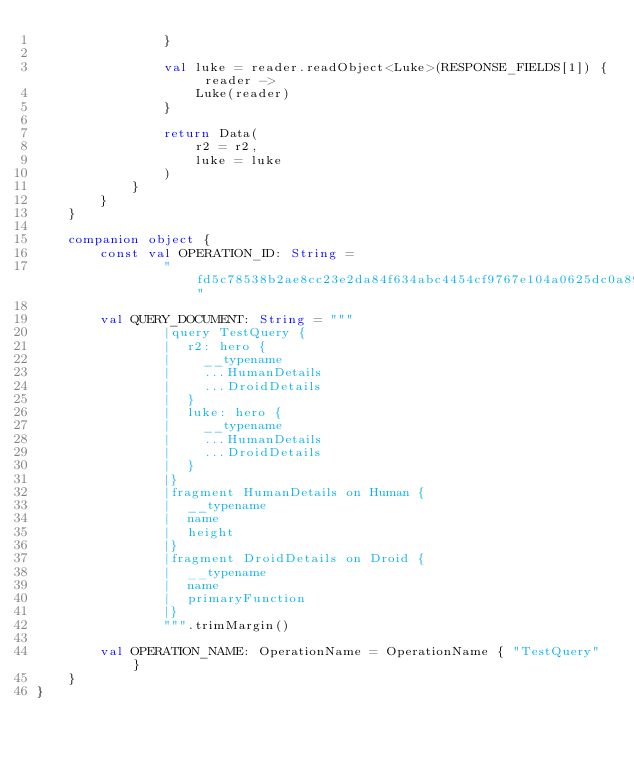<code> <loc_0><loc_0><loc_500><loc_500><_Kotlin_>                }

                val luke = reader.readObject<Luke>(RESPONSE_FIELDS[1]) { reader ->
                    Luke(reader)
                }

                return Data(
                    r2 = r2,
                    luke = luke
                )
            }
        }
    }

    companion object {
        const val OPERATION_ID: String =
                "fd5c78538b2ae8cc23e2da84f634abc4454cf9767e104a0625dc0a8917dfb121"

        val QUERY_DOCUMENT: String = """
                |query TestQuery {
                |  r2: hero {
                |    __typename
                |    ...HumanDetails
                |    ...DroidDetails
                |  }
                |  luke: hero {
                |    __typename
                |    ...HumanDetails
                |    ...DroidDetails
                |  }
                |}
                |fragment HumanDetails on Human {
                |  __typename
                |  name
                |  height
                |}
                |fragment DroidDetails on Droid {
                |  __typename
                |  name
                |  primaryFunction
                |}
                """.trimMargin()

        val OPERATION_NAME: OperationName = OperationName { "TestQuery" }
    }
}
</code> 